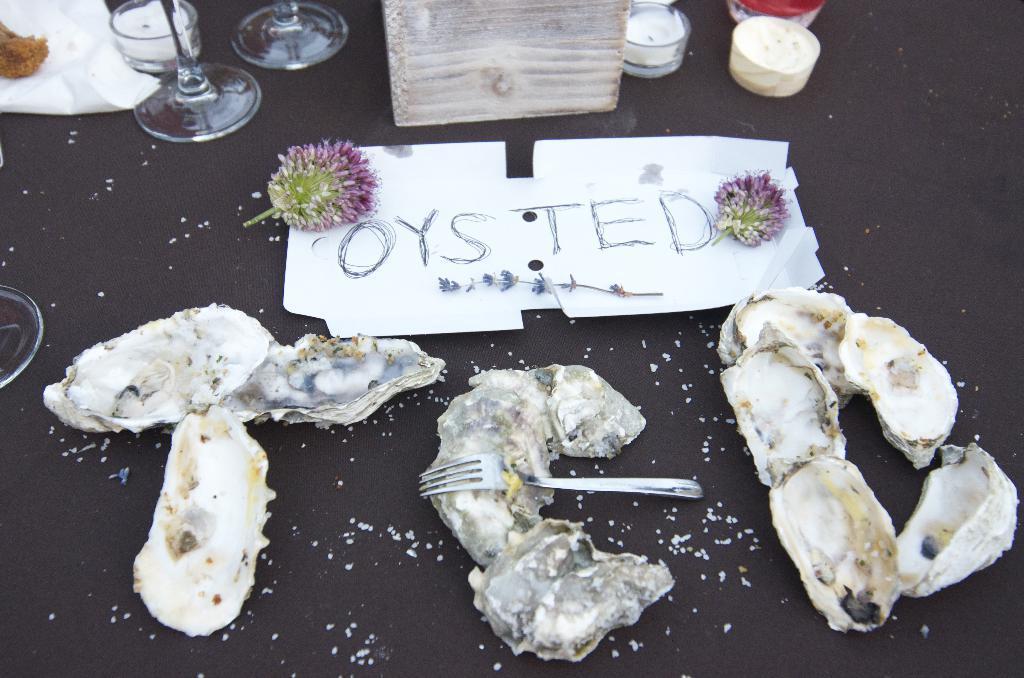Describe this image in one or two sentences. In this picture we can see a few food items, fork, flowers, text and a plant on a white object. We can see a few glasses, tissue and other objects on a black surface. 